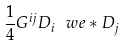Convert formula to latex. <formula><loc_0><loc_0><loc_500><loc_500>\frac { 1 } { 4 } G ^ { i j } D _ { i } \ w e * D _ { j }</formula> 